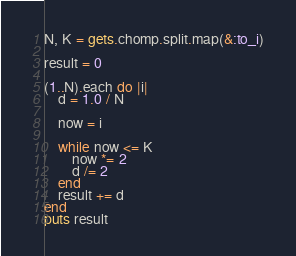<code> <loc_0><loc_0><loc_500><loc_500><_Ruby_>N, K = gets.chomp.split.map(&:to_i)

result = 0

(1..N).each do |i|
	d = 1.0 / N

	now = i

	while now <= K
		now *= 2
		d /= 2
	end
	result += d
end
puts result</code> 